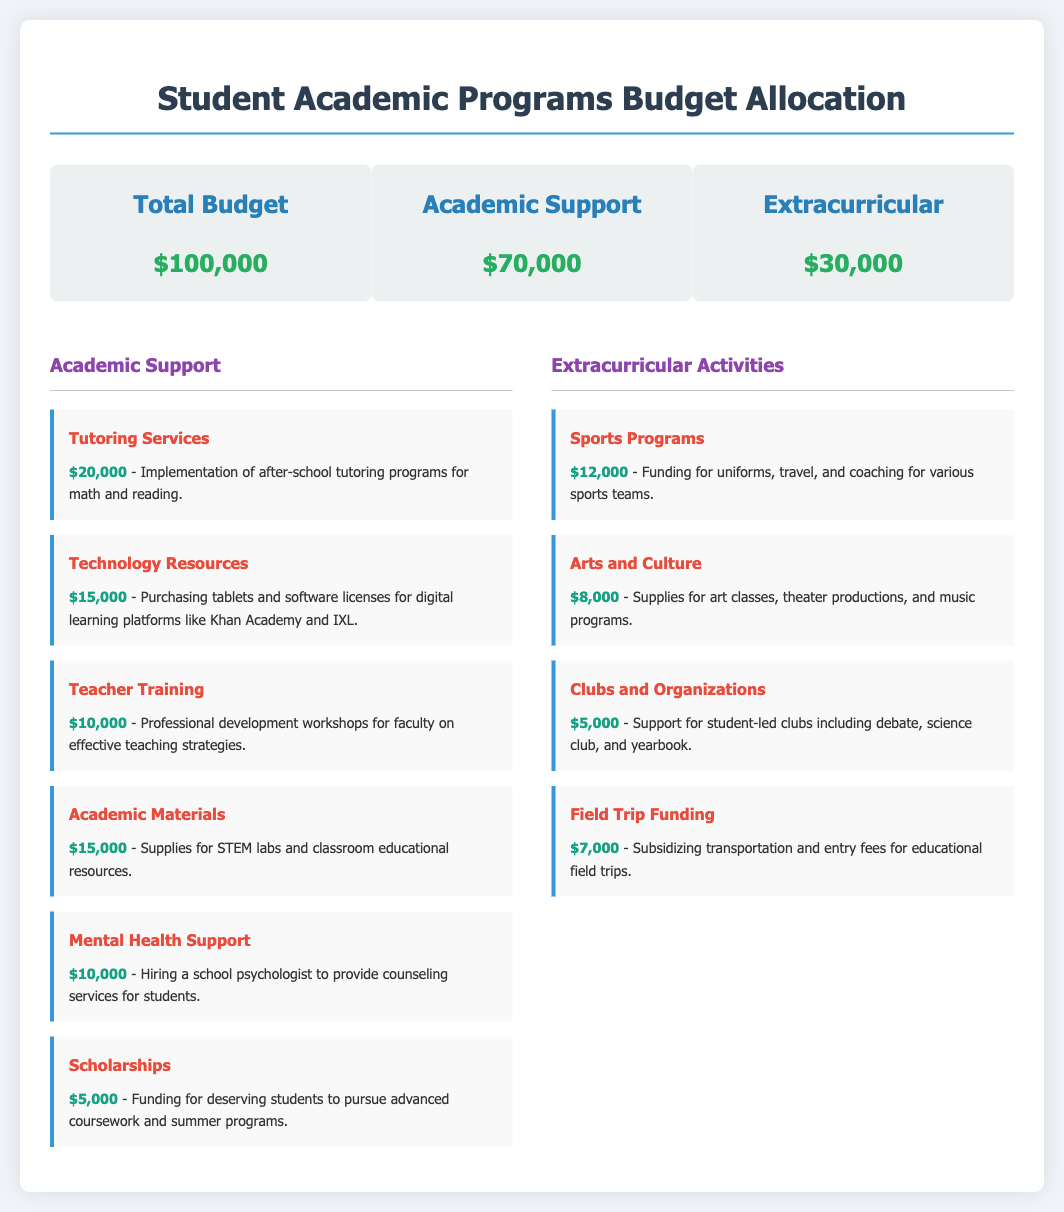What is the total budget? The total budget is displayed at the top of the document, showing the overall funding available for the academic programs.
Answer: $100,000 How much is allocated for Academic Support? The document specifies the amount designated for Academic Support, clearly outlined under the budget overview.
Answer: $70,000 What is the funding for Tutoring Services? The document lists the specific allocation for Tutoring Services under the Academic Support section.
Answer: $20,000 How much is allocated for Sports Programs? The funding for Sports Programs is detailed in the Extracurricular Activities section of the document.
Answer: $12,000 What is the total amount for Extracurricular Activities? The budget overview shows the total funding assigned for all Extracurricular Activities combined.
Answer: $30,000 How much is allocated for Mental Health Support? The document provides a breakdown of funding for Mental Health Support as part of Academic Support.
Answer: $10,000 Which program receives $15,000 for digital learning? The document mentions the program that is funding for Technology Resources specifically for digital learning platforms.
Answer: Technology Resources What is the funding for Scholarships? The allocation for Scholarships is detailed in the Academic Support section of the document.
Answer: $5,000 How much is budgeted for Field Trip Funding? The specific budget allocation for Field Trip Funding is represented in the Extracurricular Activities section.
Answer: $7,000 